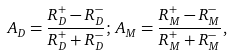Convert formula to latex. <formula><loc_0><loc_0><loc_500><loc_500>A _ { D } = \frac { R ^ { + } _ { D } - R ^ { - } _ { D } } { R ^ { + } _ { D } + R ^ { - } _ { D } } ; \, A _ { M } = \frac { R ^ { + } _ { M } - R ^ { - } _ { M } } { R ^ { + } _ { M } + R ^ { - } _ { M } } ,</formula> 